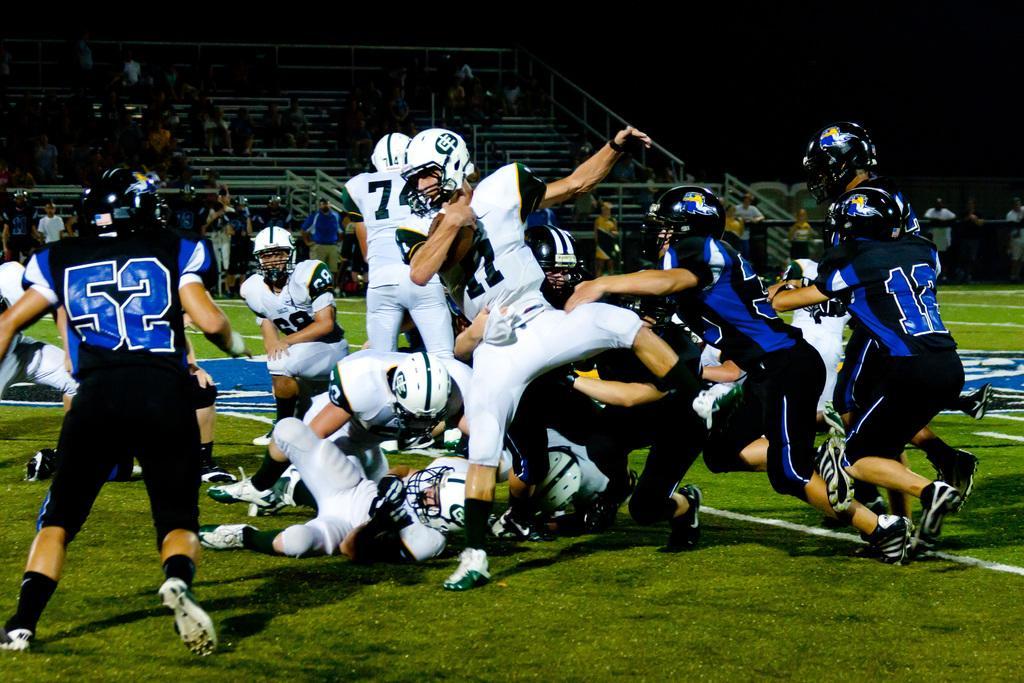Please provide a concise description of this image. In this image it looks like it is a rugby match in which there are players who are fighting with each other for the ball. In the background there are few people sitting in the stand and watching the game. 